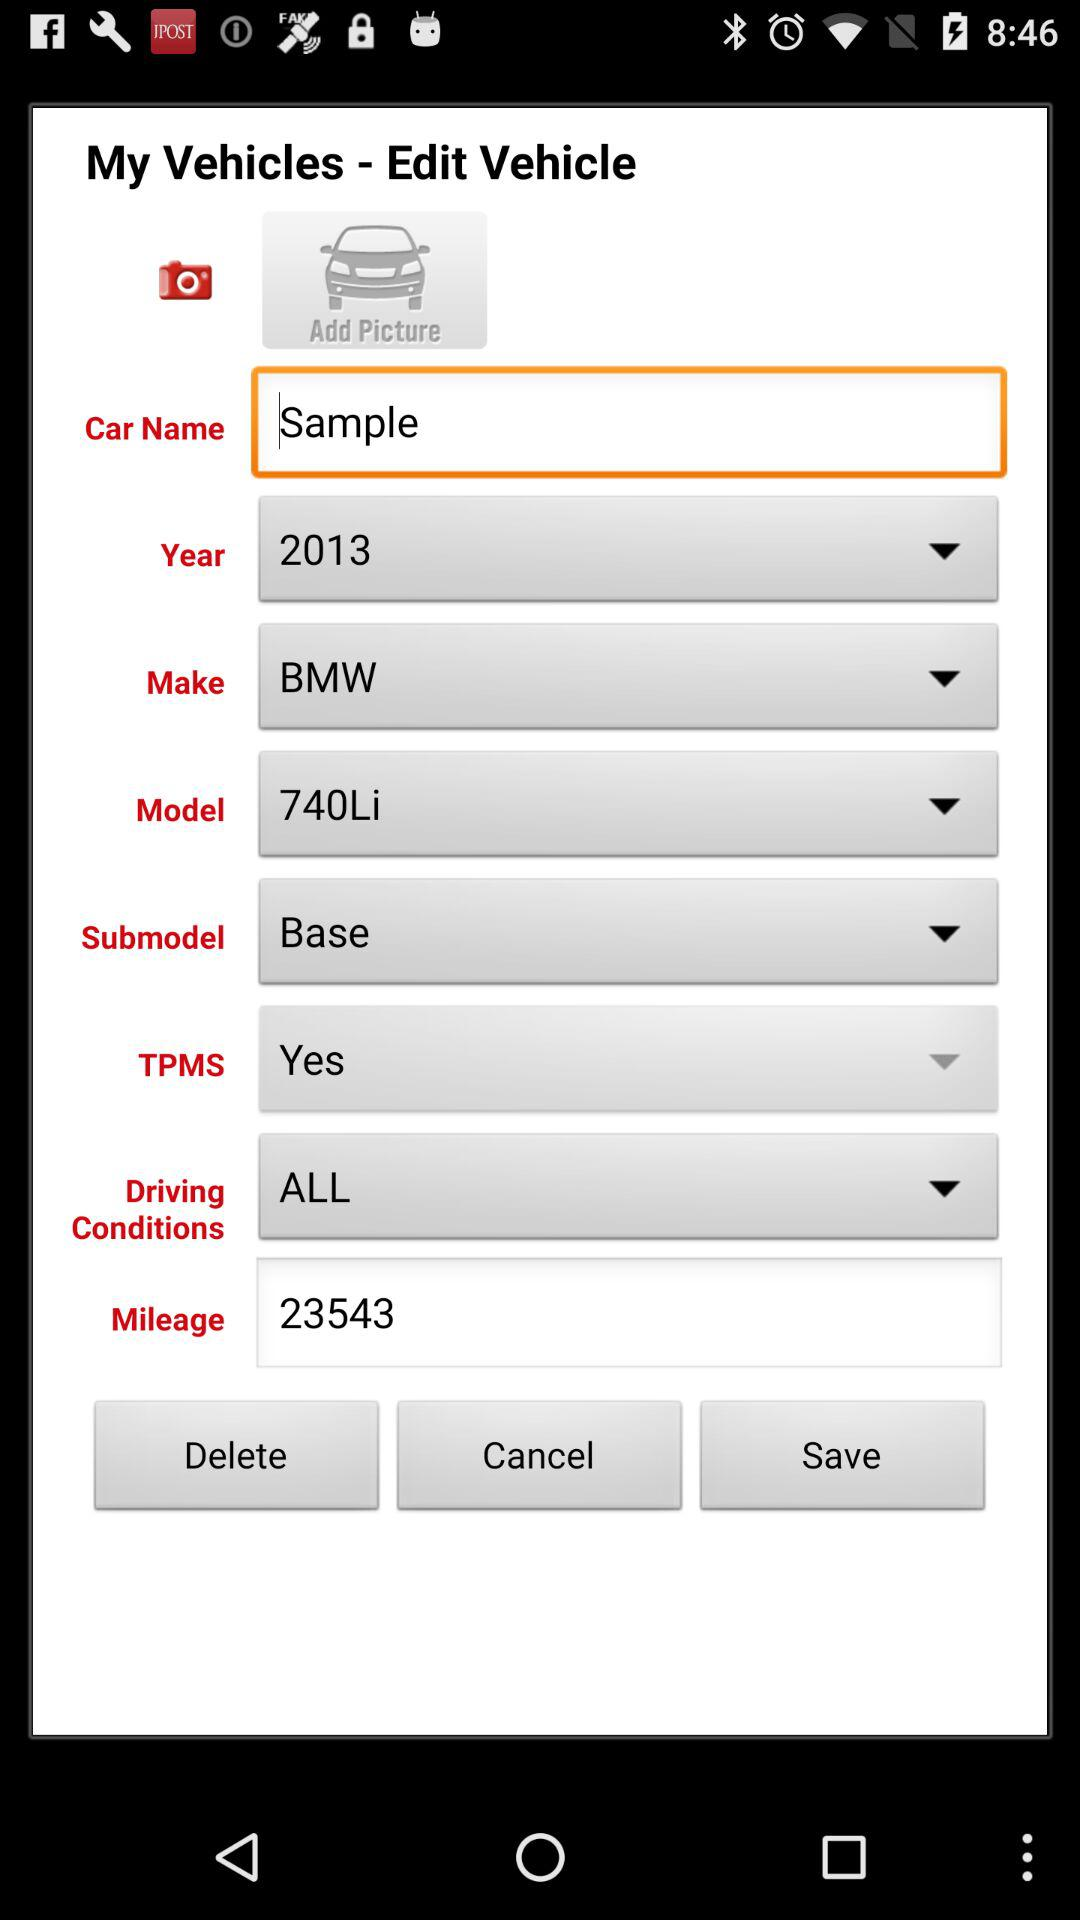What is the model? The model is "740Li". 